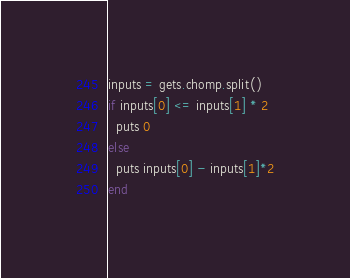Convert code to text. <code><loc_0><loc_0><loc_500><loc_500><_Ruby_>inputs = gets.chomp.split()
if inputs[0] <= inputs[1] * 2
  puts 0
else
  puts inputs[0] - inputs[1]*2
end</code> 